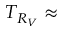<formula> <loc_0><loc_0><loc_500><loc_500>T _ { R _ { V } } \approx</formula> 